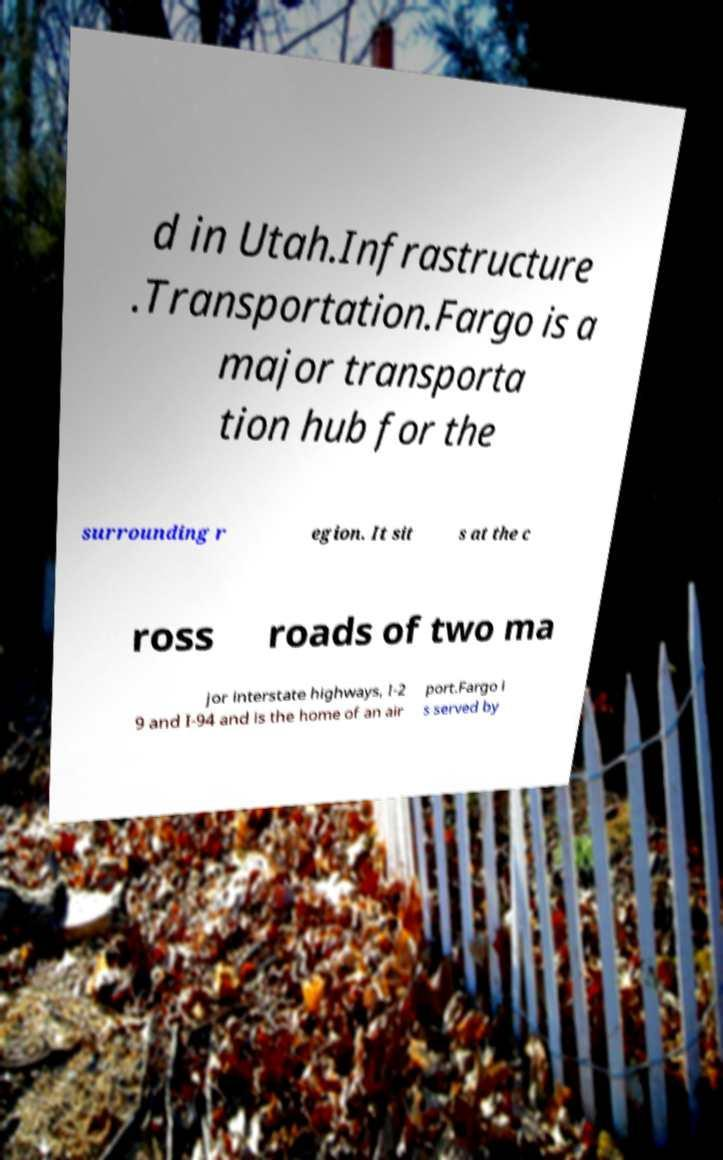I need the written content from this picture converted into text. Can you do that? d in Utah.Infrastructure .Transportation.Fargo is a major transporta tion hub for the surrounding r egion. It sit s at the c ross roads of two ma jor interstate highways, I-2 9 and I-94 and is the home of an air port.Fargo i s served by 